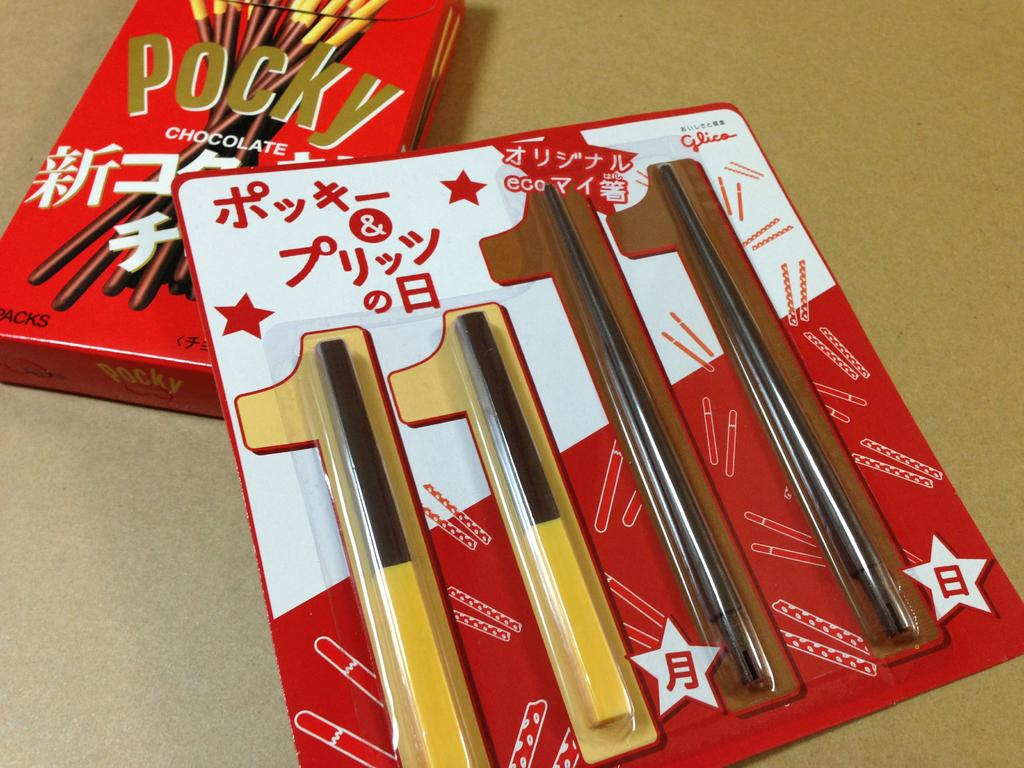What type of objects can be seen in the image? There is a packet and a box in the image. Where are these objects located? Both objects are on a surface in the image. What type of song can be heard playing in the background of the image? There is no song or audio present in the image; it only contains visual information. 